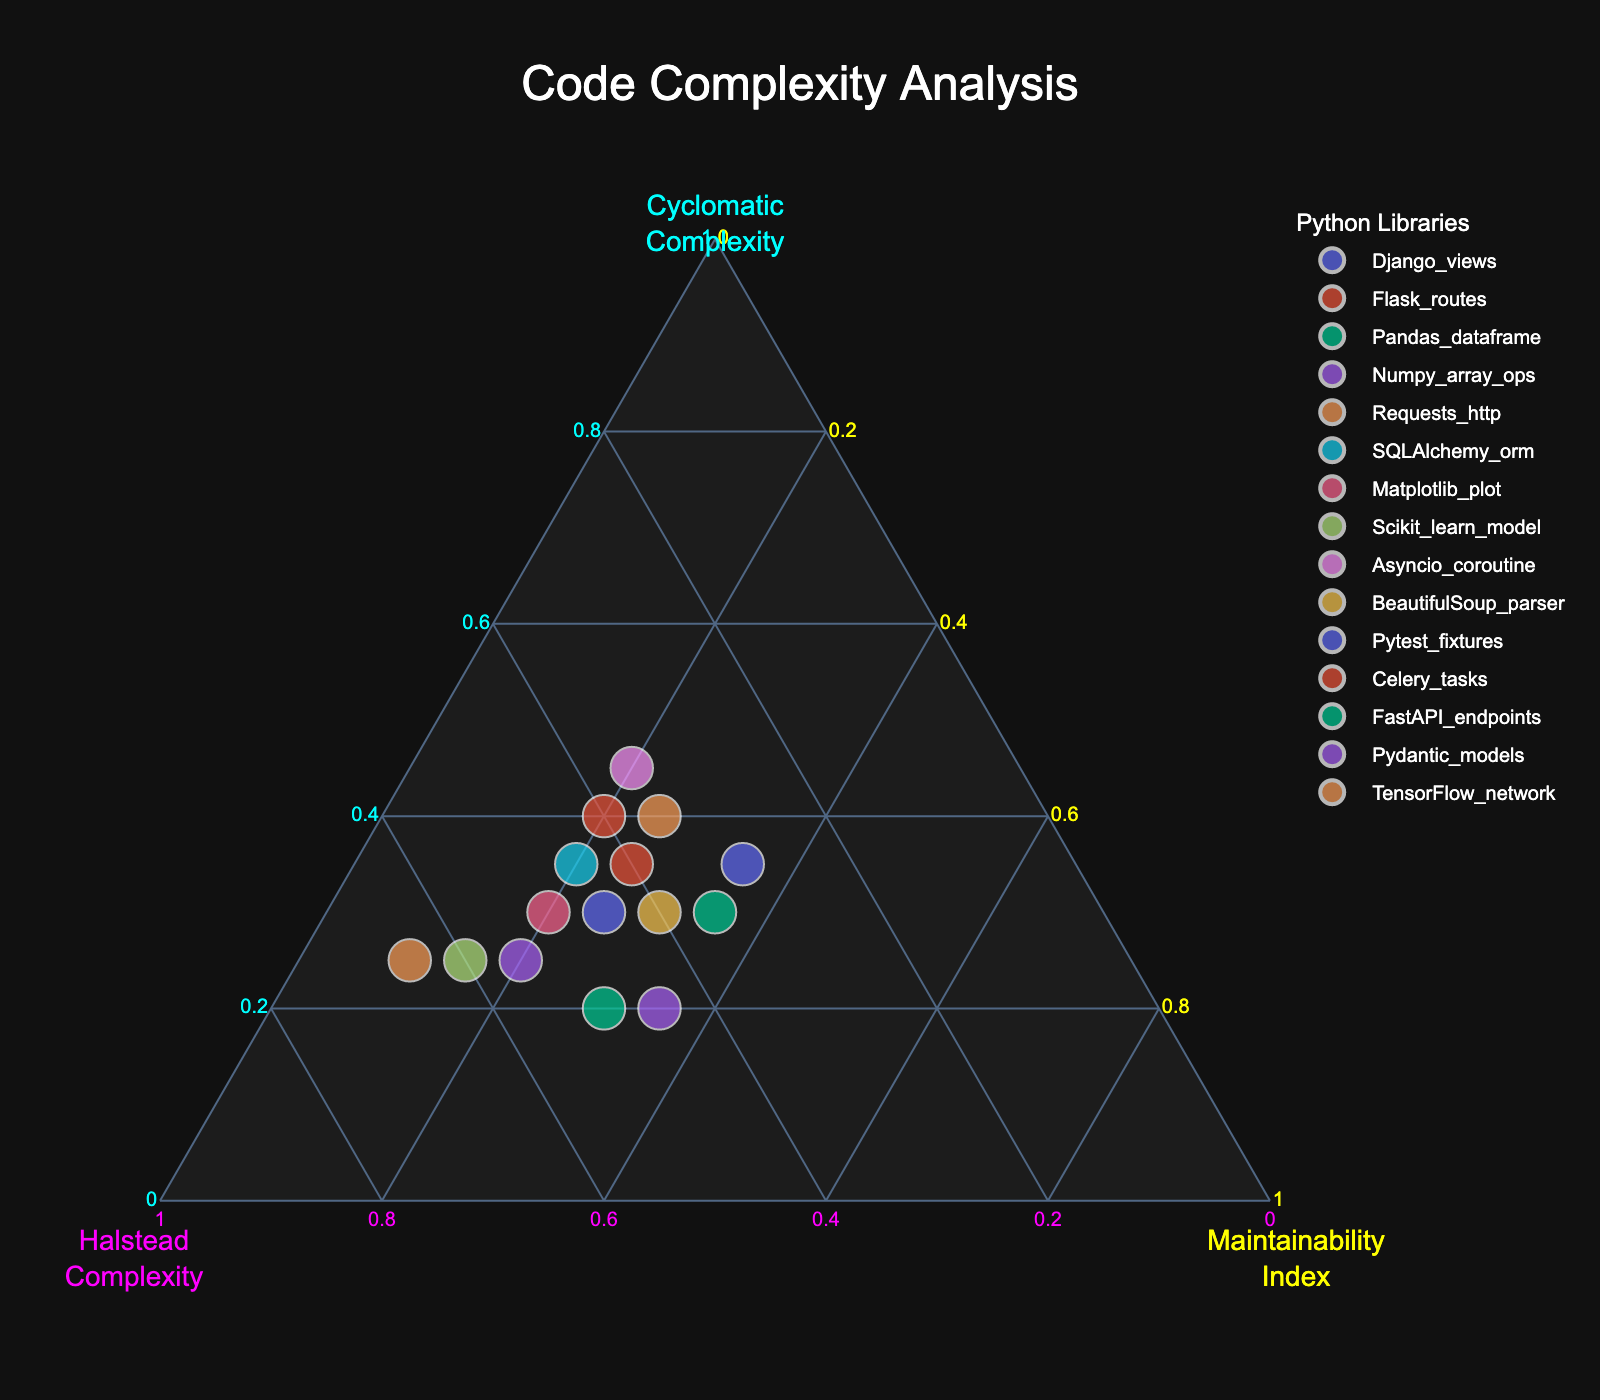What's the title of the figure? The title of a plot is typically displayed at the top and is used to inform the viewer of what the plot represents. Here, the title reads "Code Complexity Analysis".
Answer: Code Complexity Analysis What are the axes titles and their colors? The axes titles in a ternary plot correspond to the three variables being analyzed. The colors associated with the axes are cyan for Cyclomatic Complexity, magenta for Halstead Complexity, and yellow for Maintainability Index.
Answer: Cyclomatic (cyan), Halstead (magenta), Maintainability (yellow) How many metrics are being compared in this ternary plot? Each distinct data point in the plot corresponds to a separate metric. By counting the number of unique data points, we determine how many metrics are being compared. In this plot, there are 15 unique data points.
Answer: 15 Which metric has the highest Cyclomatic Complexity? We look at the plot focusing on the Cyclomatic Complexity axis (cyan) and identify which point is the farthest towards this axis. The Asyncio_coroutine metric is notably the highest on the Cyclomatic Complexity axis.
Answer: Asyncio_coroutine Which metric has the lowest Maintainability Index and what is its value? Check the position on the Maintainability Index axis (yellow) and identify the point with the lowest value. The TensorFlow_network data point shows the lowest position on this axis with a value of 10.
Answer: TensorFlow_network, 10 Comparing Flask_routes and Requests_http, which has a higher Halstead Complexity? By locating the points for Flask_routes and Requests_http on the plot and observing their positions relative to the Halstead Complexity axis (magenta), it's clear that Flask_routes is slightly higher on this axis than Requests_http.
Answer: Flask_routes What's the average value of Maintainability Index for Django_views, Flask_routes, and Pandas_dataframe? First, observe the Maintainability Index values for each metric: Django_views (25), Flask_routes (25), Pandas_dataframe (30). Calculate the average: (25 + 25 + 30)/3 = 26.67.
Answer: 26.67 In terms of Halstead Complexity, which metric has the highest value and what is that value? Look along the Halstead Complexity axis (magenta) and find the farthest point towards this axis. The TensorFlow_network metric has the highest value here, which is 65.
Answer: TensorFlow_network, 65 Which metrics have the same Maintainability Index of 35? Observe the plot and identify points that align with the Maintainability Index value of 35: FastAPI_endpoints, Pydantic_models, and Pytest_fixtures all appear at this level.
Answer: FastAPI_endpoints, Pydantic_models, Pytest_fixtures Comparing Numpy_array_ops and Requests_http, which has a higher Cyclomatic Complexity? Check the positions for Numpy_array_ops and Requests_http along the Cyclomatic Complexity axis (cyan) and note that Requests_http is positioned further towards this axis.
Answer: Requests_http 